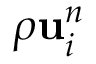Convert formula to latex. <formula><loc_0><loc_0><loc_500><loc_500>\rho { u } _ { i } ^ { n }</formula> 